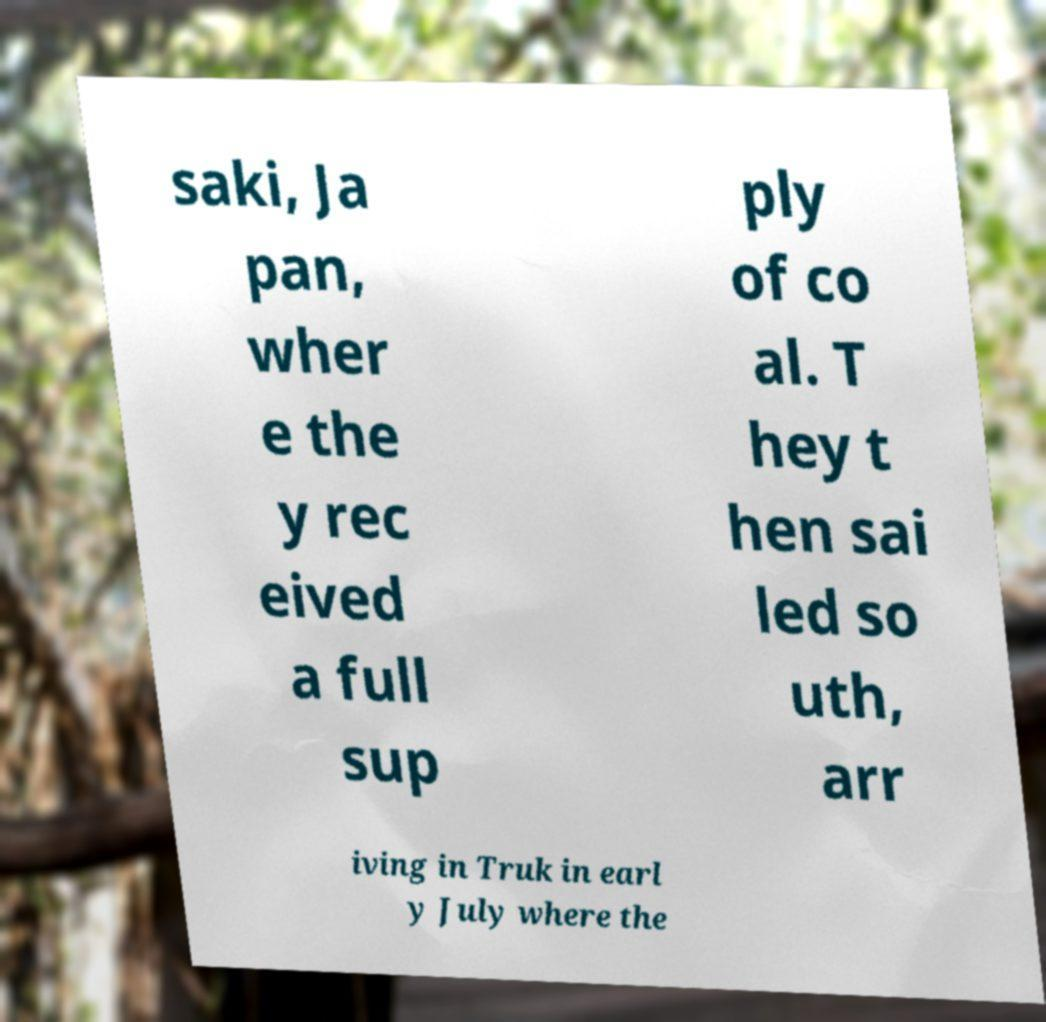Please read and relay the text visible in this image. What does it say? saki, Ja pan, wher e the y rec eived a full sup ply of co al. T hey t hen sai led so uth, arr iving in Truk in earl y July where the 